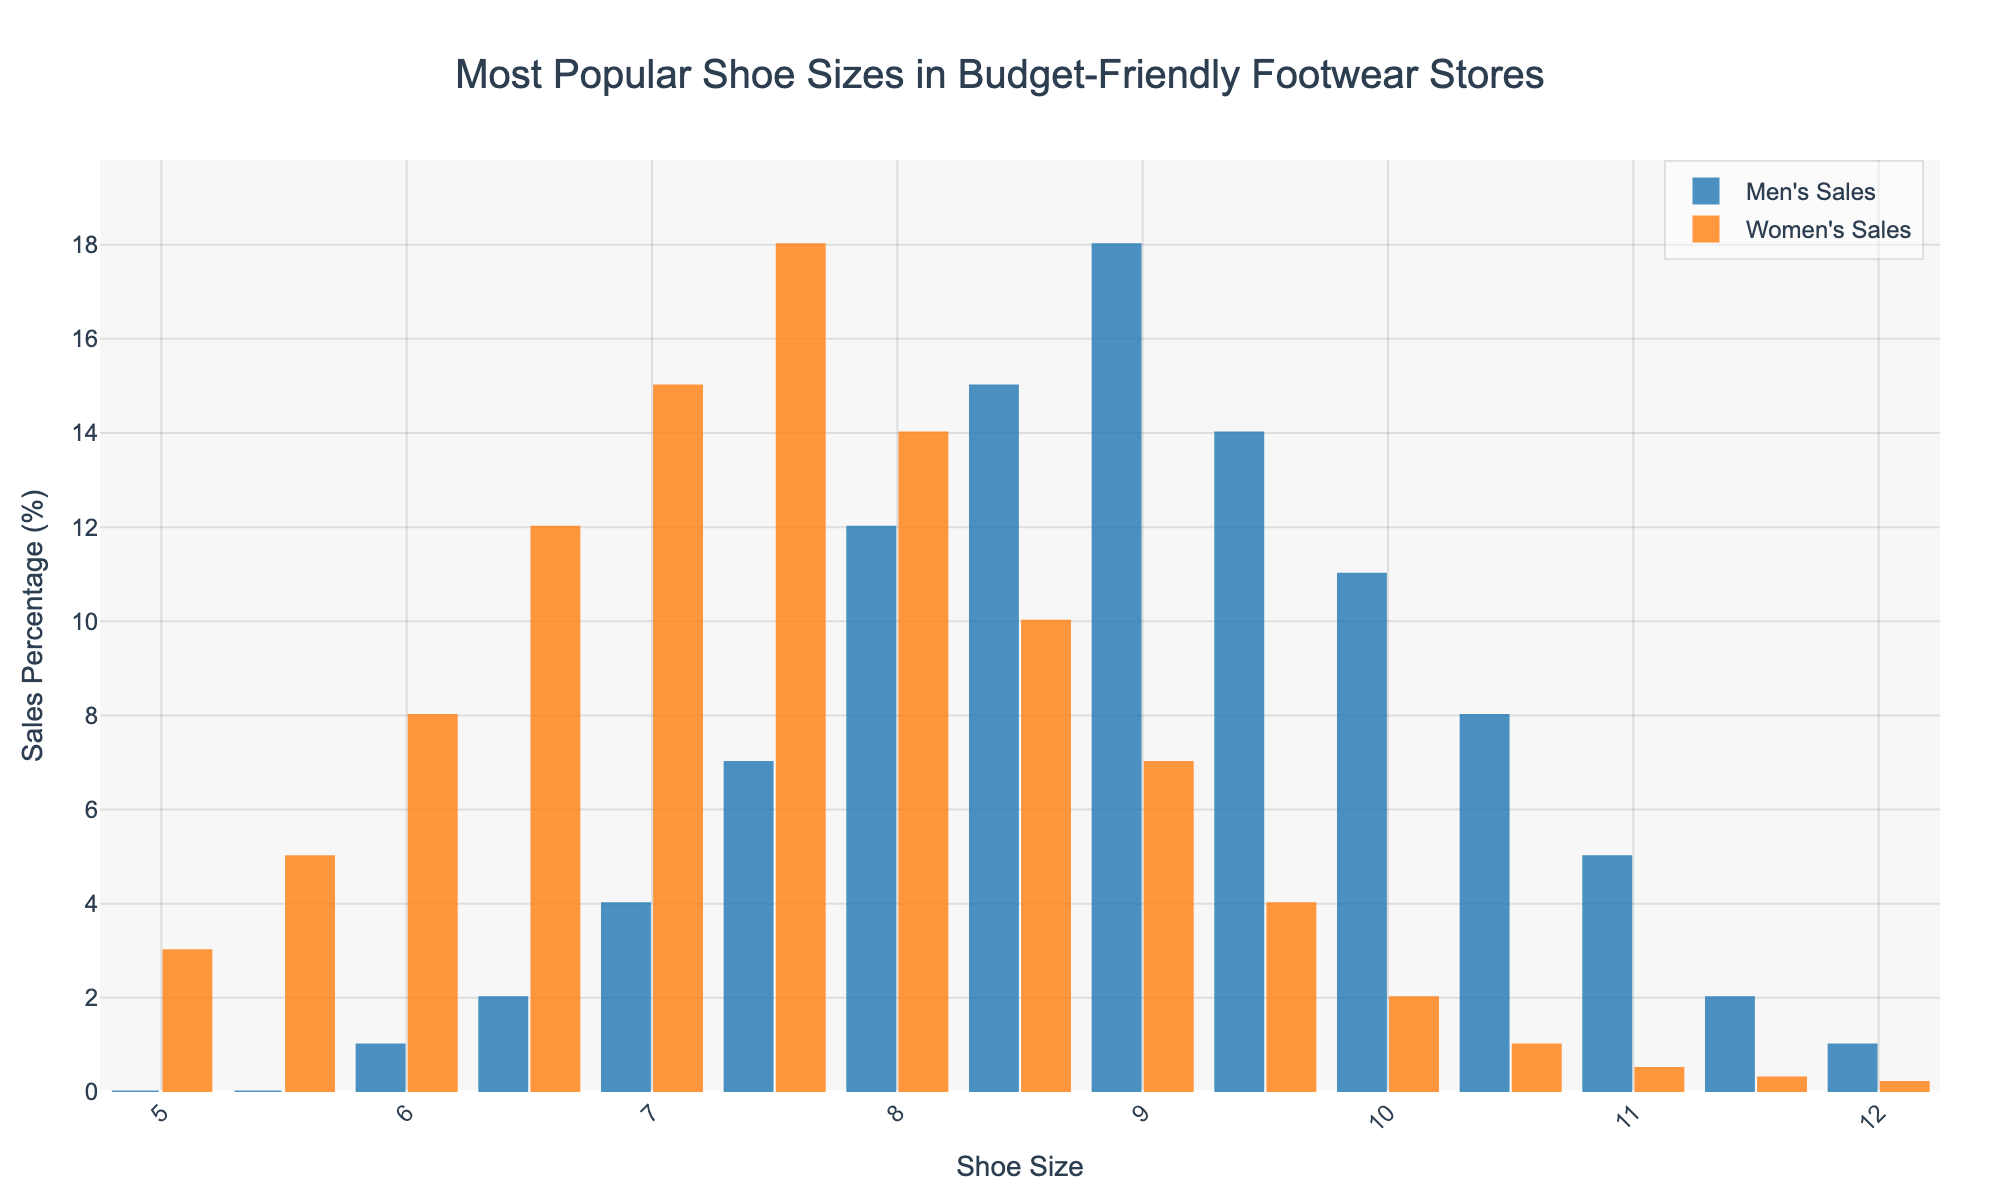What is the most popular men's shoe size in budget-friendly footwear stores? The bar representing the men's shoe size 9 has the highest percentage.
Answer: 9 Which shoe size has a higher sales percentage for women than for men and what are the respective percentages? Sizes 5, 5.5, 6, 6.5, 7, 7.5, and 8 show higher percentages in women's sales compared to men's sales. For example, size 6.5 has 12% for women compared to 2% for men.
Answer: 5, 5.5, 6, 6.5, 7, 7.5, 8 Compare the sales percentages of shoe size 8.5 for men and women. Which is higher? The bar for men's sales at size 8.5 is higher than the bar for women's sales at the same size. Men have 15% while women have 10%.
Answer: Men's sales What is the total sales percentage for shoe sizes 9 and 9.5 for men? Summing the percentages for sizes 9 and 9.5 for men: 18% + 14% = 32%.
Answer: 32% For which shoe size do women have the highest sales percentage, and what is the percentage? The bar for women's sales at shoe size 7.5 is the tallest, indicating the highest sales percentage, which is 18%.
Answer: 7.5, 18% Does any shoe size have equal sales percentages for men and women? If so, what is the size and percentage? There are no bars that are exactly equal in height for both men and women in the chart.
Answer: None Calculate the average men's sales percentage for shoe sizes from 8 to 10.5. Average = (12% + 15% + 18% + 14% + 11% + 8%) / 6 = 13%.
Answer: 13% Are there any shoe sizes where the sales percentage for men is zero? The bars for men's sales at shoe sizes 5 and 5.5 are not visible, indicating 0%.
Answer: 5, 5.5 Which gender has a higher sales percentage for shoe size 10.5, and what are the percentages? The bar for men's sales at size 10.5 is higher than for women's sales. Men have 8% while women have 1%.
Answer: Men, 8%, 1% Compare the overall trends in shoe sizes sold for men and women. What observation can you make? Men's shoe sales percentages tend to peak at larger sizes (8.5, 9) while women's sales peak at smaller sizes (7.5, 7).
Answer: Men prefer larger sizes; women prefer smaller sizes 